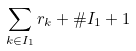Convert formula to latex. <formula><loc_0><loc_0><loc_500><loc_500>\sum _ { k \in I _ { 1 } } r _ { k } + \# I _ { 1 } + 1</formula> 